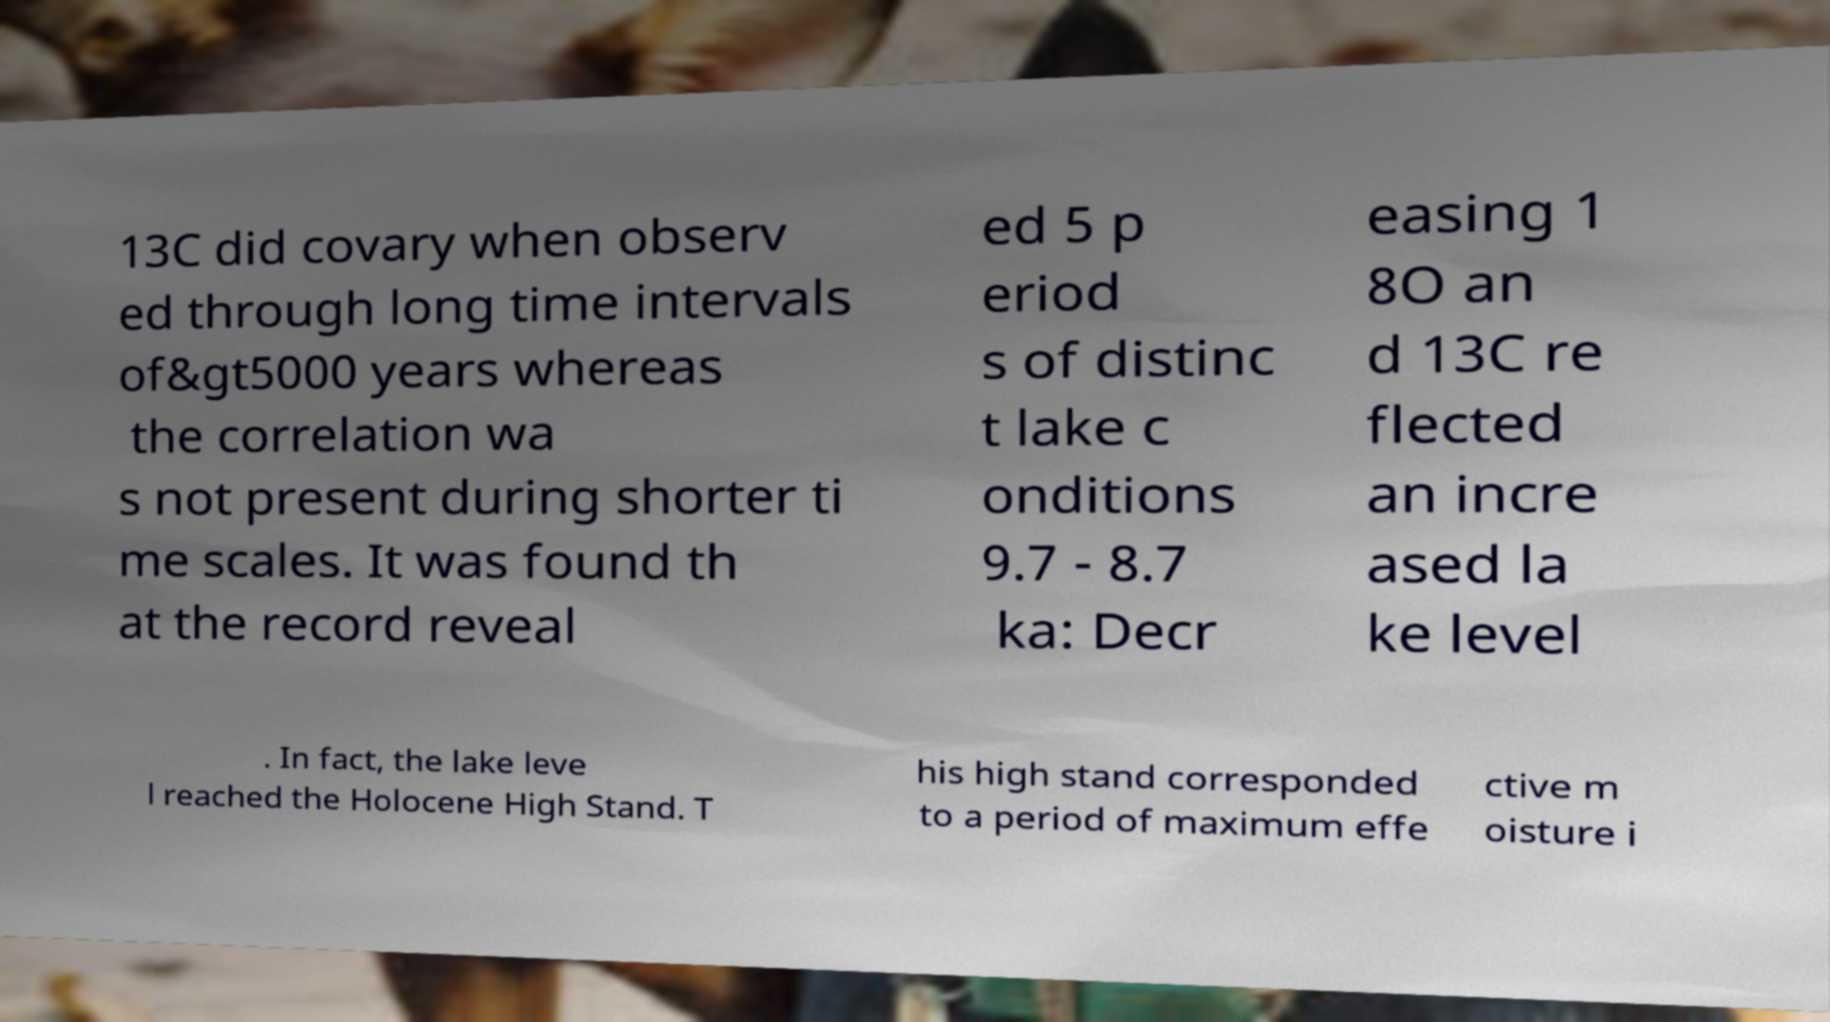Please identify and transcribe the text found in this image. 13C did covary when observ ed through long time intervals of&gt5000 years whereas the correlation wa s not present during shorter ti me scales. It was found th at the record reveal ed 5 p eriod s of distinc t lake c onditions 9.7 - 8.7 ka: Decr easing 1 8O an d 13C re flected an incre ased la ke level . In fact, the lake leve l reached the Holocene High Stand. T his high stand corresponded to a period of maximum effe ctive m oisture i 